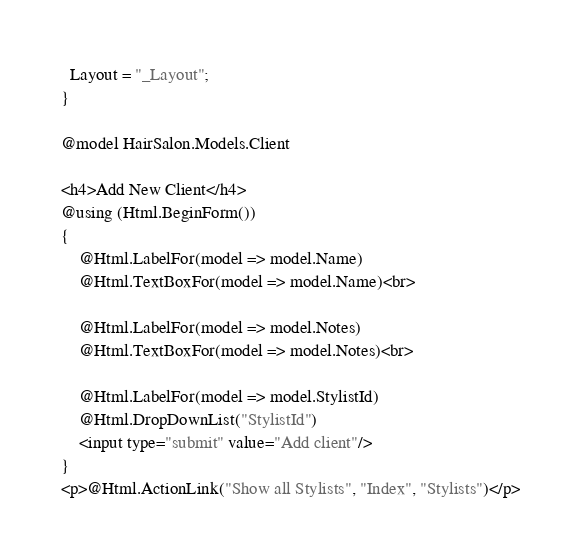<code> <loc_0><loc_0><loc_500><loc_500><_C#_>  Layout = "_Layout";
}

@model HairSalon.Models.Client

<h4>Add New Client</h4>
@using (Html.BeginForm())
{
    @Html.LabelFor(model => model.Name)
    @Html.TextBoxFor(model => model.Name)<br>

    @Html.LabelFor(model => model.Notes)
    @Html.TextBoxFor(model => model.Notes)<br>

    @Html.LabelFor(model => model.StylistId)
    @Html.DropDownList("StylistId")
    <input type="submit" value="Add client"/>
}
<p>@Html.ActionLink("Show all Stylists", "Index", "Stylists")</p>
</code> 